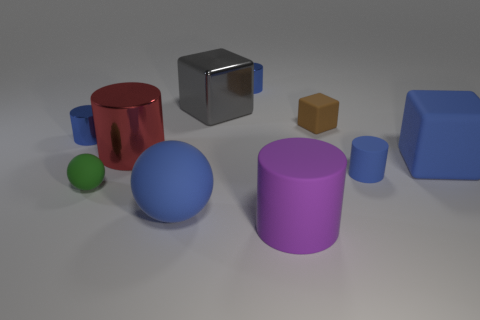How many other things are made of the same material as the brown object?
Your answer should be compact. 5. What is the shape of the big blue rubber thing to the right of the big matte cylinder that is right of the big cylinder that is behind the purple thing?
Your response must be concise. Cube. Is the number of small blue metal things to the right of the small cube less than the number of blue objects that are left of the purple rubber cylinder?
Give a very brief answer. Yes. Is there a rubber block that has the same color as the big ball?
Provide a short and direct response. Yes. Is the brown object made of the same material as the small blue cylinder left of the green sphere?
Make the answer very short. No. Are there any brown blocks that are behind the big blue thing on the left side of the big purple object?
Your response must be concise. Yes. There is a rubber object that is both to the right of the small matte ball and left of the big purple thing; what is its color?
Provide a short and direct response. Blue. What is the size of the metal cube?
Your answer should be very brief. Large. What number of green matte objects have the same size as the purple cylinder?
Offer a terse response. 0. Do the object in front of the large blue matte ball and the tiny blue cylinder to the left of the metallic block have the same material?
Give a very brief answer. No. 